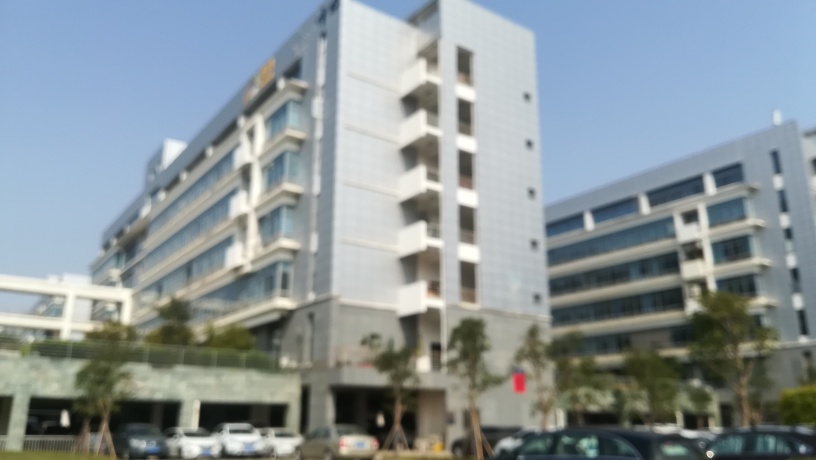What kind of vehicles can be seen in the parking lot? Even with the focusing issues, we can discern that the parking lot is filled with cars. Due to the blurriness of the image, specifics about the makes and models are not distinguishable. 